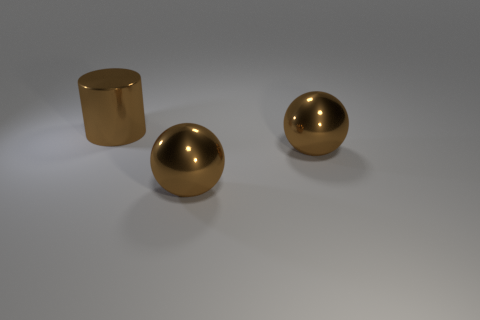Add 2 large brown objects. How many objects exist? 5 Subtract 1 spheres. How many spheres are left? 1 Subtract all gray cylinders. Subtract all gray spheres. How many cylinders are left? 1 Subtract all blue blocks. How many yellow cylinders are left? 0 Subtract all metal objects. Subtract all yellow rubber cylinders. How many objects are left? 0 Add 1 brown things. How many brown things are left? 4 Add 3 small yellow balls. How many small yellow balls exist? 3 Subtract 0 yellow blocks. How many objects are left? 3 Subtract all balls. How many objects are left? 1 